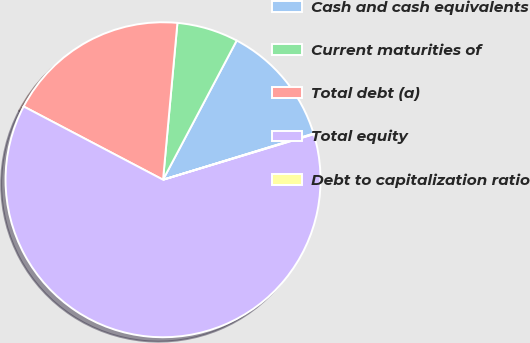Convert chart. <chart><loc_0><loc_0><loc_500><loc_500><pie_chart><fcel>Cash and cash equivalents<fcel>Current maturities of<fcel>Total debt (a)<fcel>Total equity<fcel>Debt to capitalization ratio<nl><fcel>12.52%<fcel>6.29%<fcel>18.75%<fcel>62.37%<fcel>0.06%<nl></chart> 